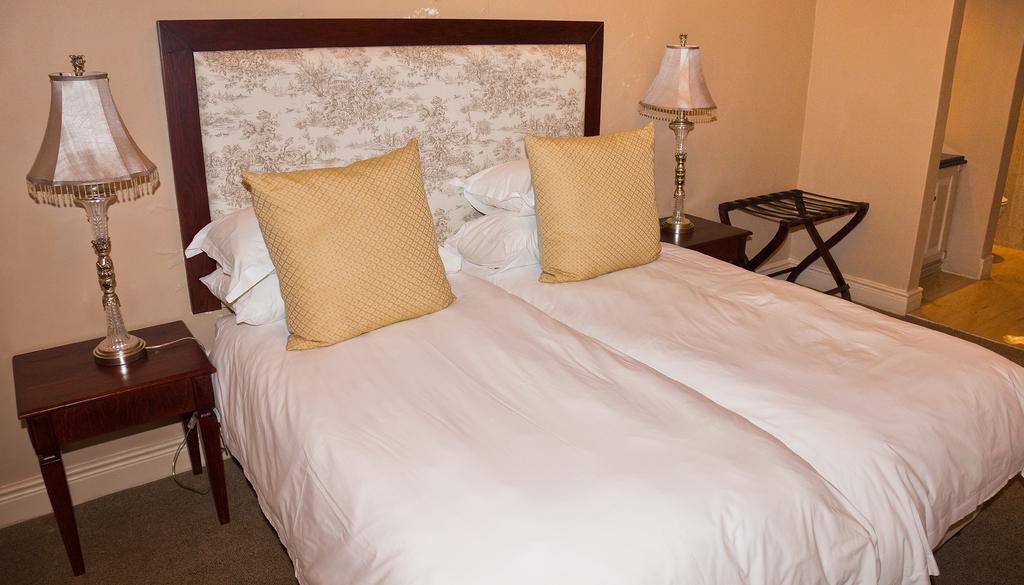Could you give a brief overview of what you see in this image? This is a bed covered with white blanket. These are the pillows and cushions. This is a table with a lamp. 